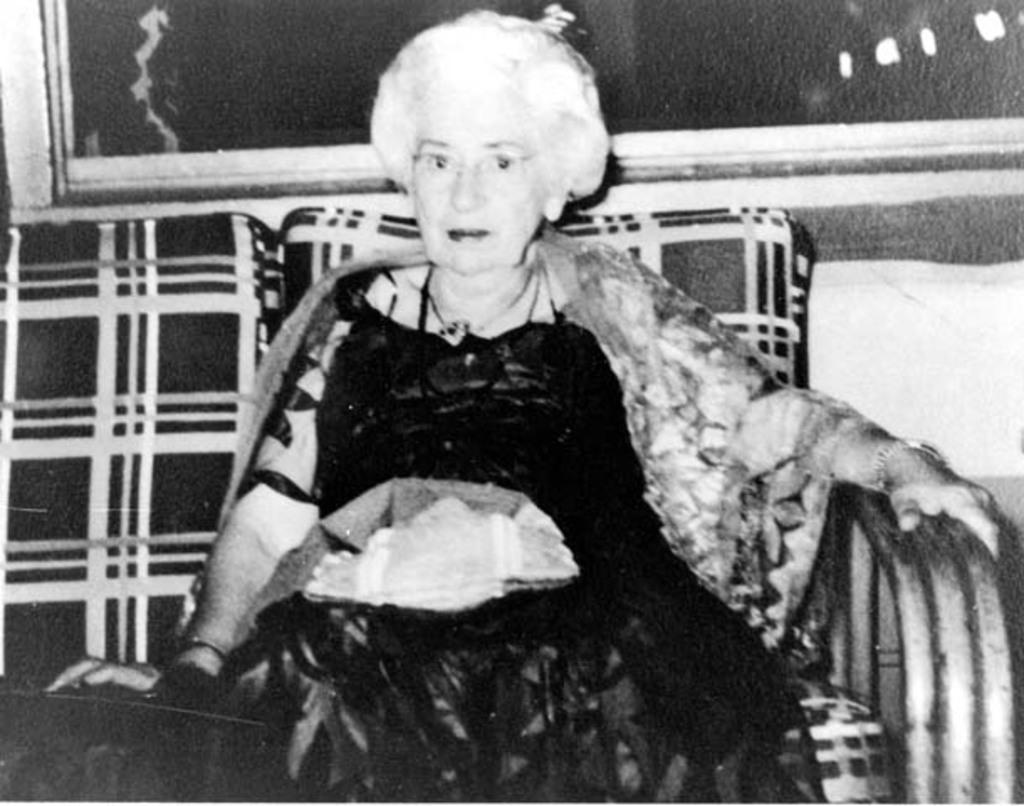What is the color scheme of the image? The image is black and white. What is the main subject of the image? There is a woman in the image. What is the woman doing in the image? The woman is sitting on a chair. What type of smell can be detected from the image? There is no smell present in the image, as it is a visual representation. What type of stamp is visible on the woman's forehead in the image? There is no stamp visible on the woman's forehead in the image. 